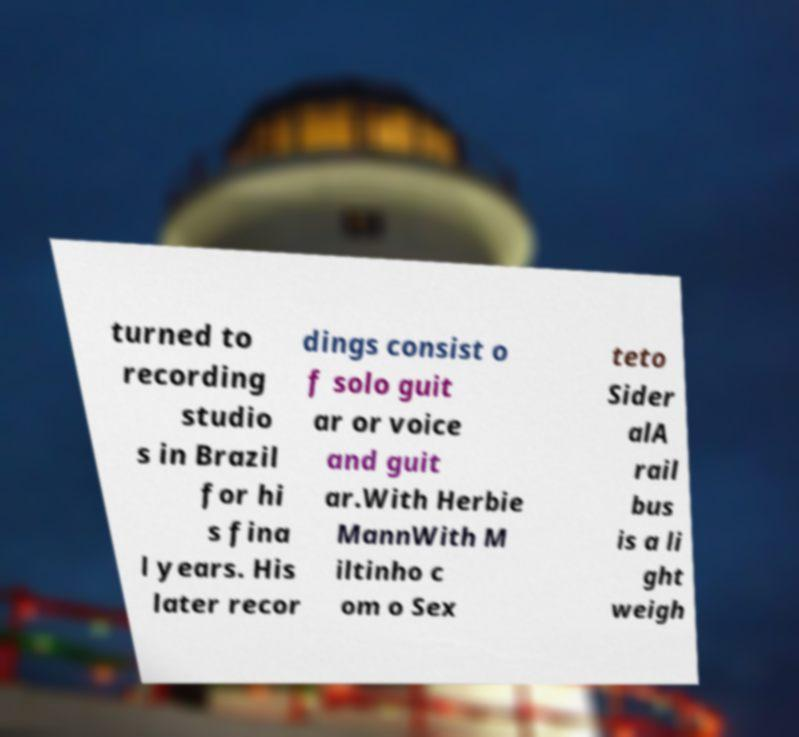Can you read and provide the text displayed in the image?This photo seems to have some interesting text. Can you extract and type it out for me? turned to recording studio s in Brazil for hi s fina l years. His later recor dings consist o f solo guit ar or voice and guit ar.With Herbie MannWith M iltinho c om o Sex teto Sider alA rail bus is a li ght weigh 